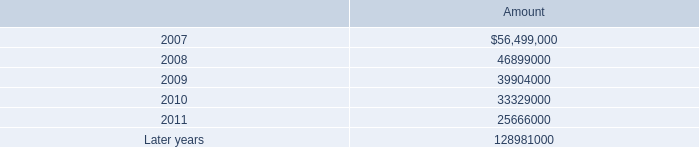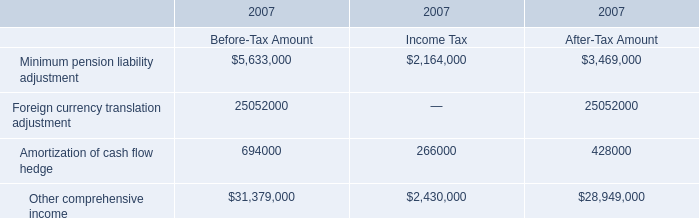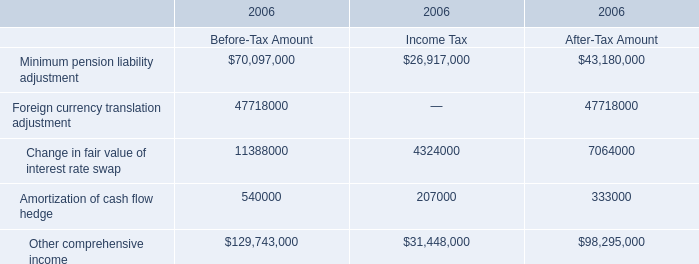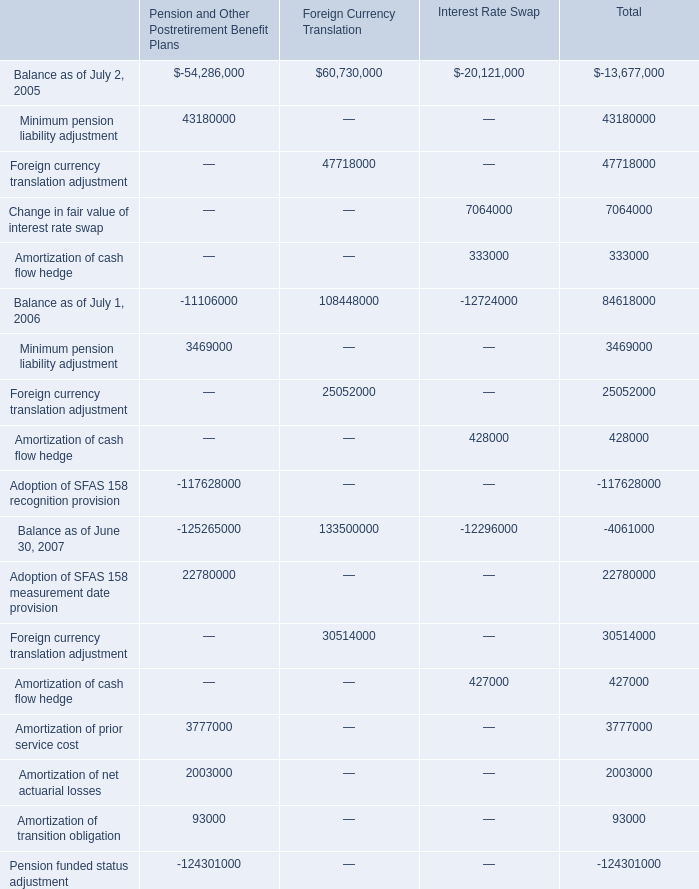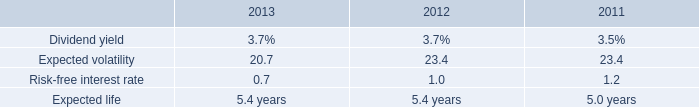What is the Income Tax for Other comprehensive income in 2006? 
Answer: 31448000. 